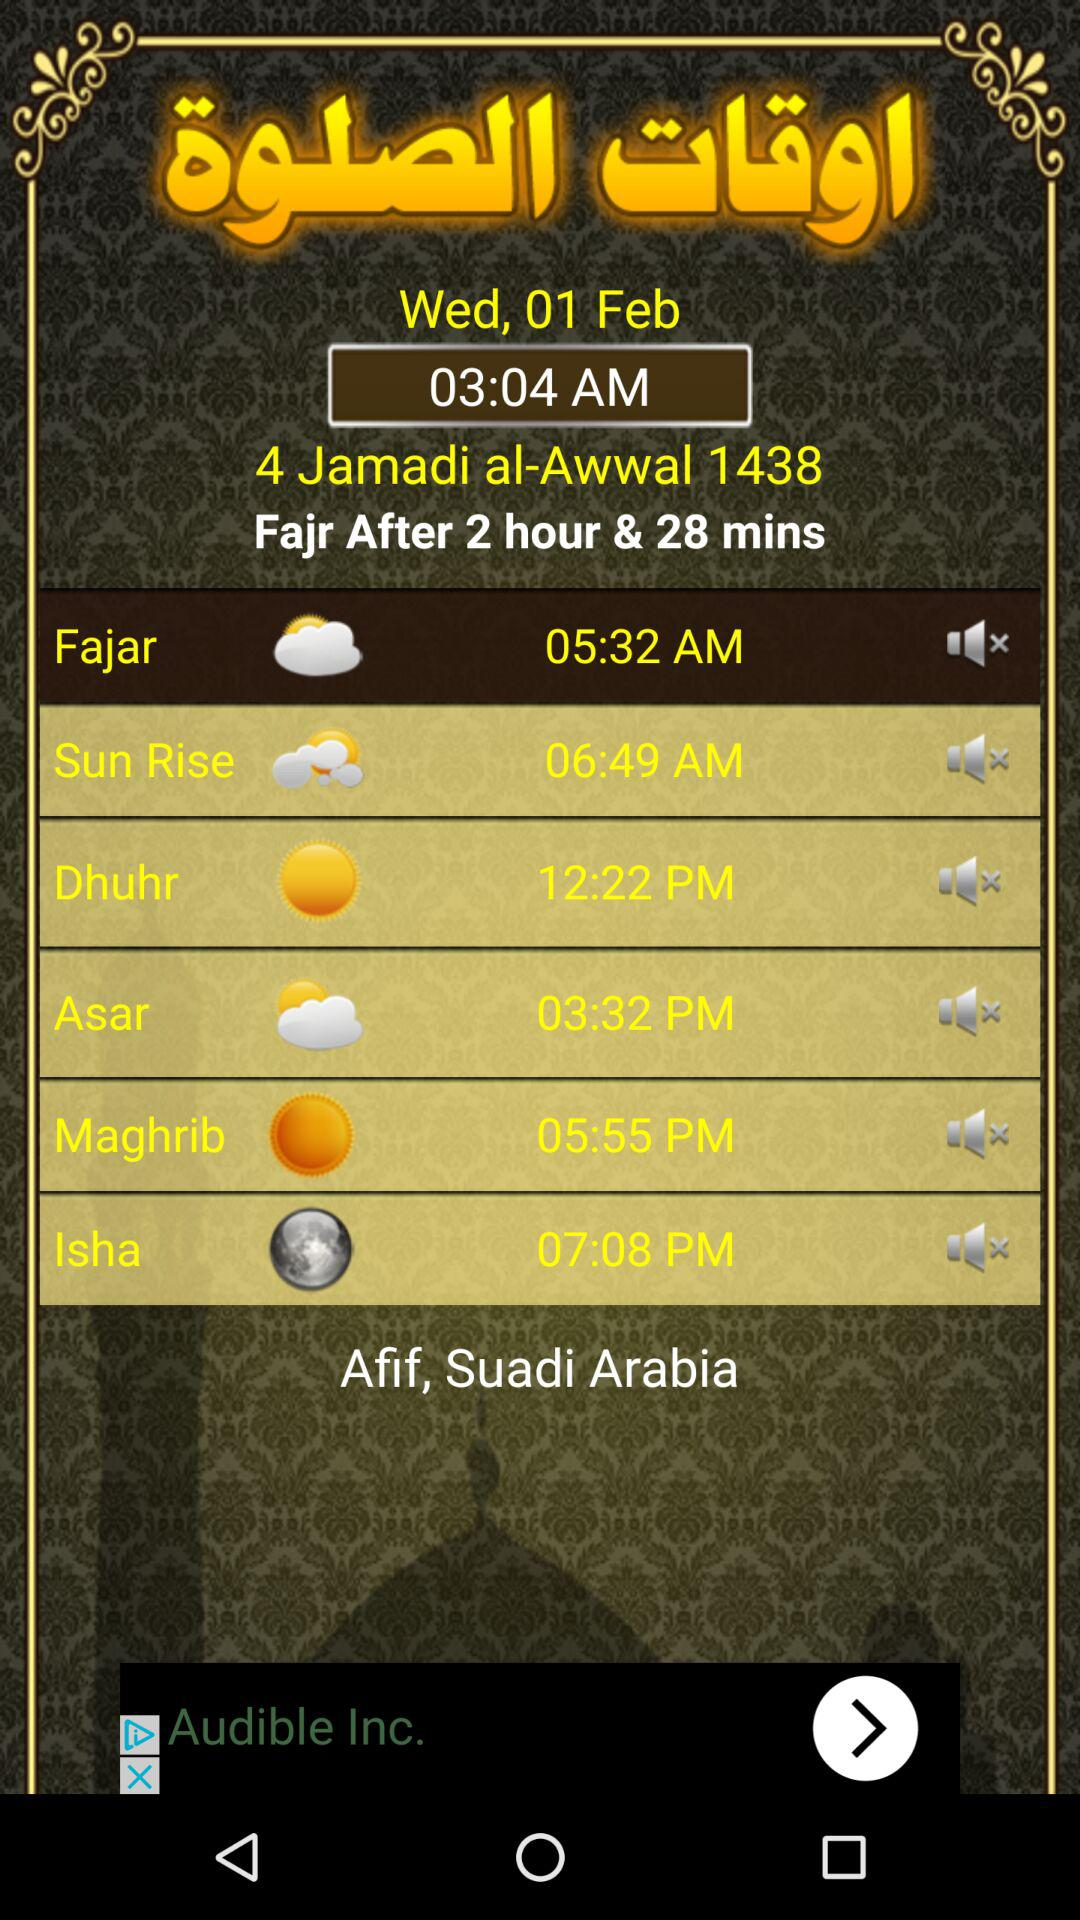What is the time of "Fajar"? The time of "Fajar" is 05:32 AM. 